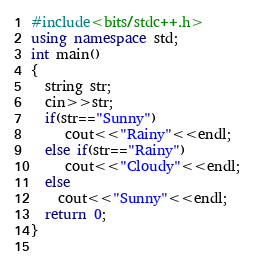<code> <loc_0><loc_0><loc_500><loc_500><_C++_>#include<bits/stdc++.h>
using namespace std;
int main()
{
  string str;
  cin>>str;
  if(str=="Sunny")
     cout<<"Rainy"<<endl;
  else if(str=="Rainy")
     cout<<"Cloudy"<<endl;
  else
    cout<<"Sunny"<<endl;
  return 0;
}
  </code> 